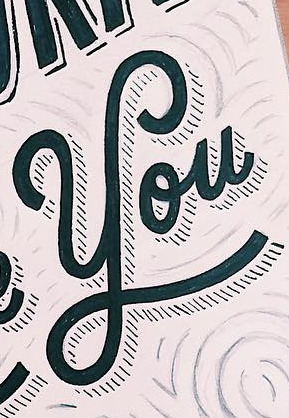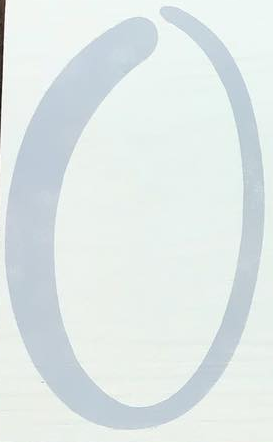What text is displayed in these images sequentially, separated by a semicolon? You; O 